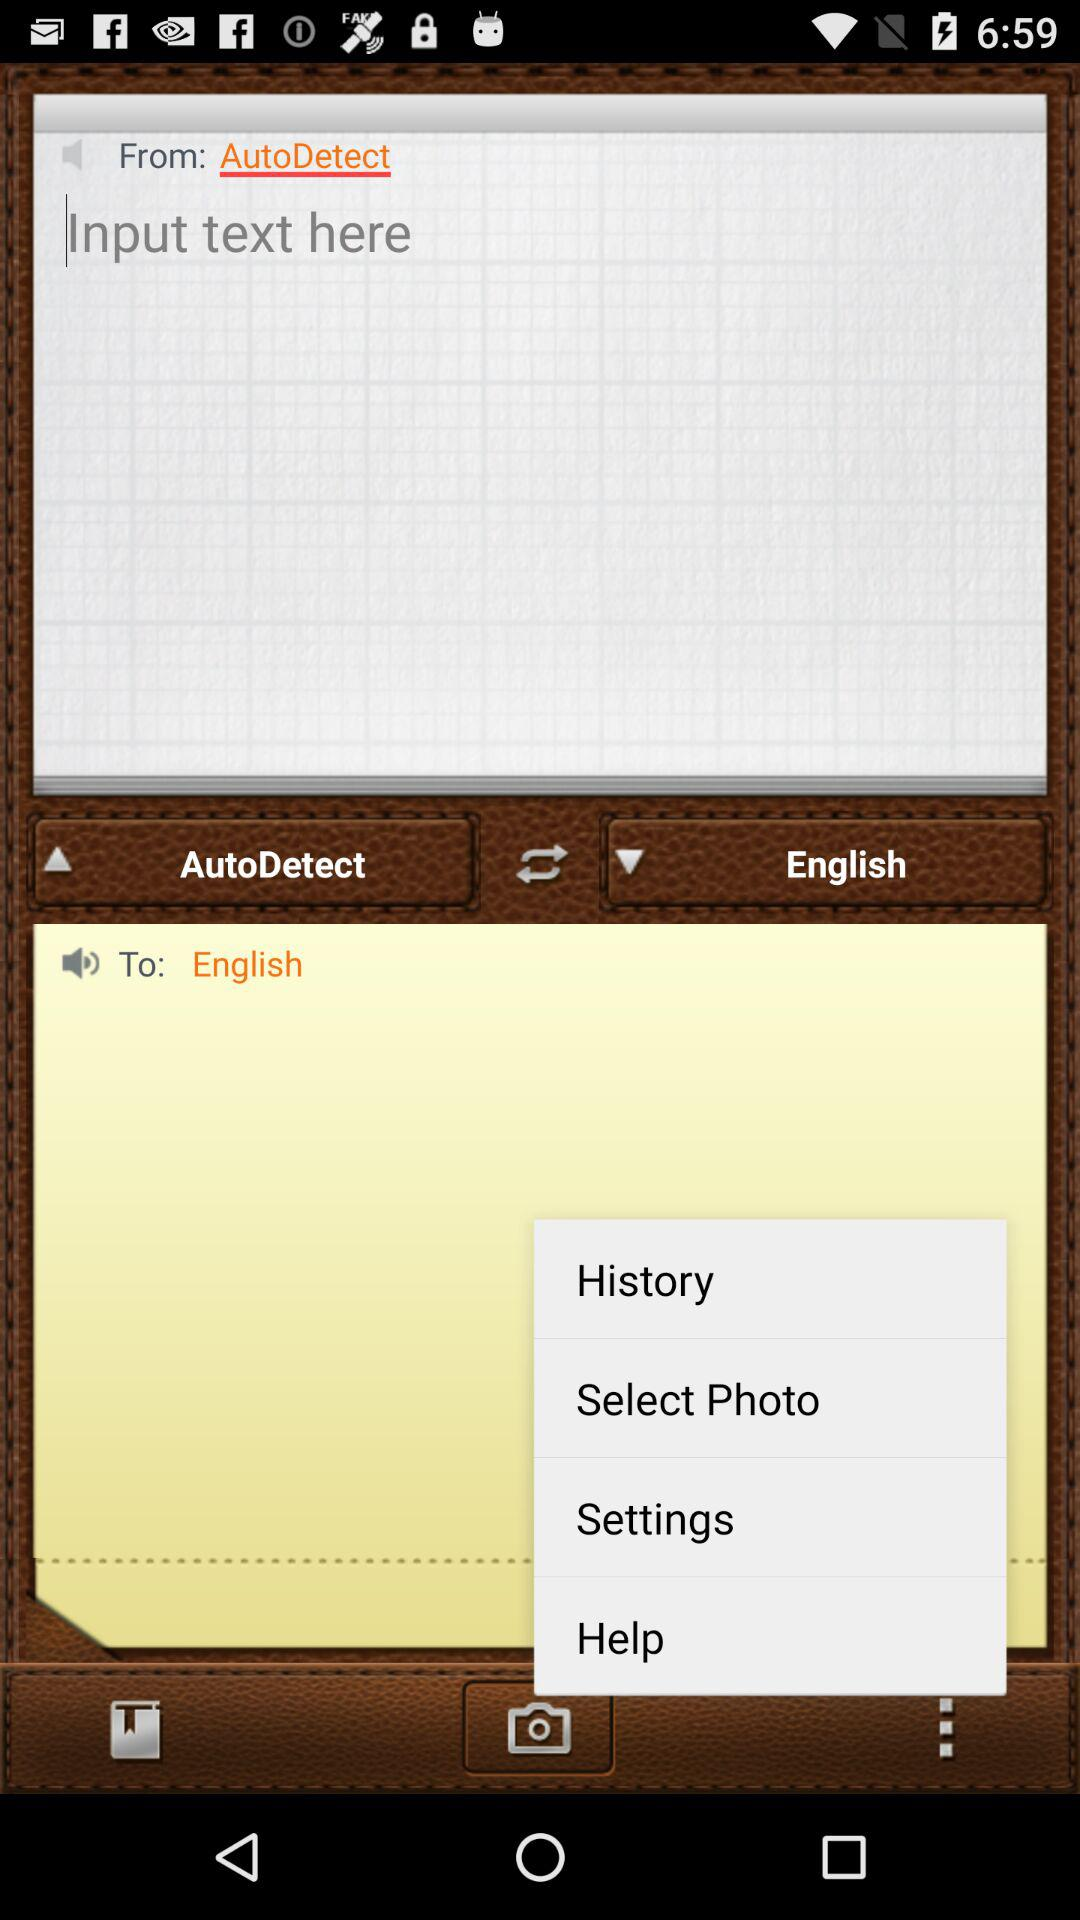How many text fields are there on this screen?
Answer the question using a single word or phrase. 2 